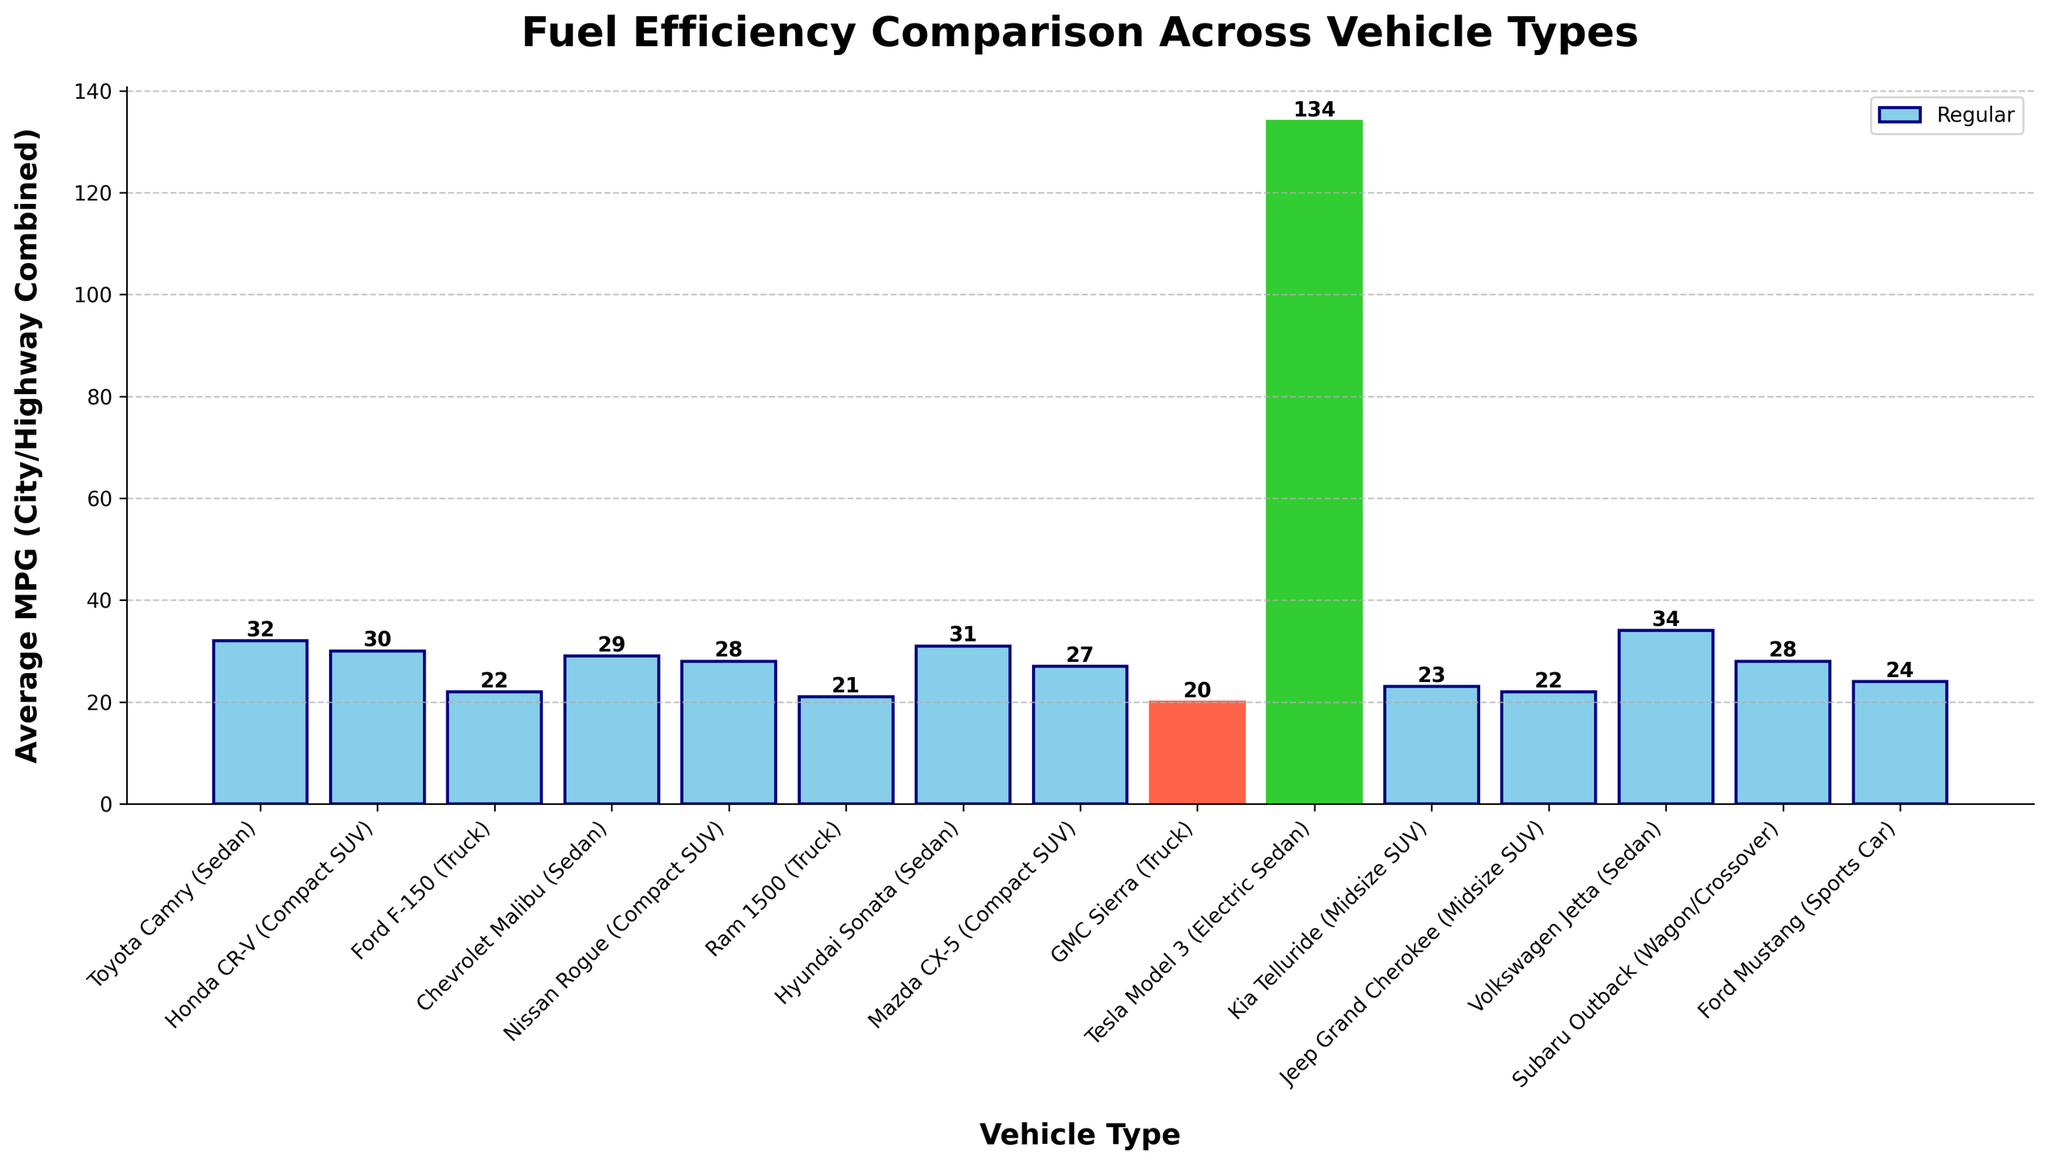What's the average MPG of the sedan category? To find the average MPG of the sedan category, sum the average MPG values of all sedans and divide by the number of sedans. The sedans are: Toyota Camry (32), Chevrolet Malibu (29), Hyundai Sonata (31), Tesla Model 3 (134), Volkswagen Jetta (34). (32 + 29 + 31 + 134 + 34) / 5 = 52
Answer: 52 Which vehicle has the highest MPG value? Identify the highest bar and read its label. The Tesla Model 3 has the highest MPG value of 134, visually indicated by its tall green bar.
Answer: Tesla Model 3 What is the difference in MPG between the highest and lowest MPG vehicles? Identify the highest (Tesla Model 3 at 134 MPG) and lowest (GMC Sierra at 20 MPG) MPG values. Subtract the lowest from the highest: 134 - 20 = 114
Answer: 114 Which vehicle types have been highlighted in lime green and tomato colors and why? The lime green bar indicates the highest MPG (Tesla Model 3), while the tomato bar indicates the lowest MPG (GMC Sierra).
Answer: Tesla Model 3 and GMC Sierra How does the average MPG of compact SUVs compare to midsize SUVs? Calculate the averages for compact SUVs (Honda CR-V: 30, Nissan Rogue: 28, Mazda CX-5: 27) and midsize SUVs (Kia Telluride: 23, Jeep Grand Cherokee: 22). Compact SUVs: (30 + 28 + 27) / 3 = 28.33. Midsize SUVs: (23 + 22) / 2 = 22.5. Compare the averages: 28.33 vs. 22.5.
Answer: Compact SUVs have a higher average MPG than midsize SUVs Which vehicle types have an MPG between 20 and 30? Identify the bars between the MPG values of 20 and 30. Honda CR-V, Chevrolet Malibu, Nissan Rogue, Mazda CX-5, Subaru Outback, Kia Telluride, Jeep Grand Cherokee, Ford Mustang meet the criteria.
Answer: Honda CR-V, Chevrolet Malibu, Nissan Rogue, Mazda CX-5, Subaru Outback, Kia Telluride, Jeep Grand Cherokee, Ford Mustang What is the color used to highlight the vehicle with the highest MPG? The vehicle with the highest MPG (Tesla Model 3) is highlighted in lime green as indicated in the legend.
Answer: Lime green Which sedan has the second highest MPG and what is the value? Among the sedans, excluding the Tesla Model 3 (134), identify the second highest bar. The Volkswagen Jetta has the second highest MPG at 34.
Answer: Volkswagen Jetta, 34 What's the combined average MPG for all SUV categories? Calculate the total MPG for all SUVs and divide by the number of SUVs. SUVs: Honda CR-V (30), Nissan Rogue (28), Mazda CX-5 (27), Kia Telluride (23), Jeep Grand Cherokee (22). (30 + 28 + 27 + 23 + 22) / 5 = 26
Answer: 26 Which type of vehicle generally has a lower MPG between trucks and compact SUVs? Compare the average MPG values of trucks (Ford F-150: 22, Ram 1500: 21, GMC Sierra: 20) and compact SUVs (Honda CR-V: 30, Nissan Rogue: 28, Mazda CX-5: 27). Average for trucks: (22 + 21 + 20) / 3 = 21. Average for compact SUVs: (30 + 28 + 27) / 3 = 28.33.
Answer: Trucks generally have a lower MPG 